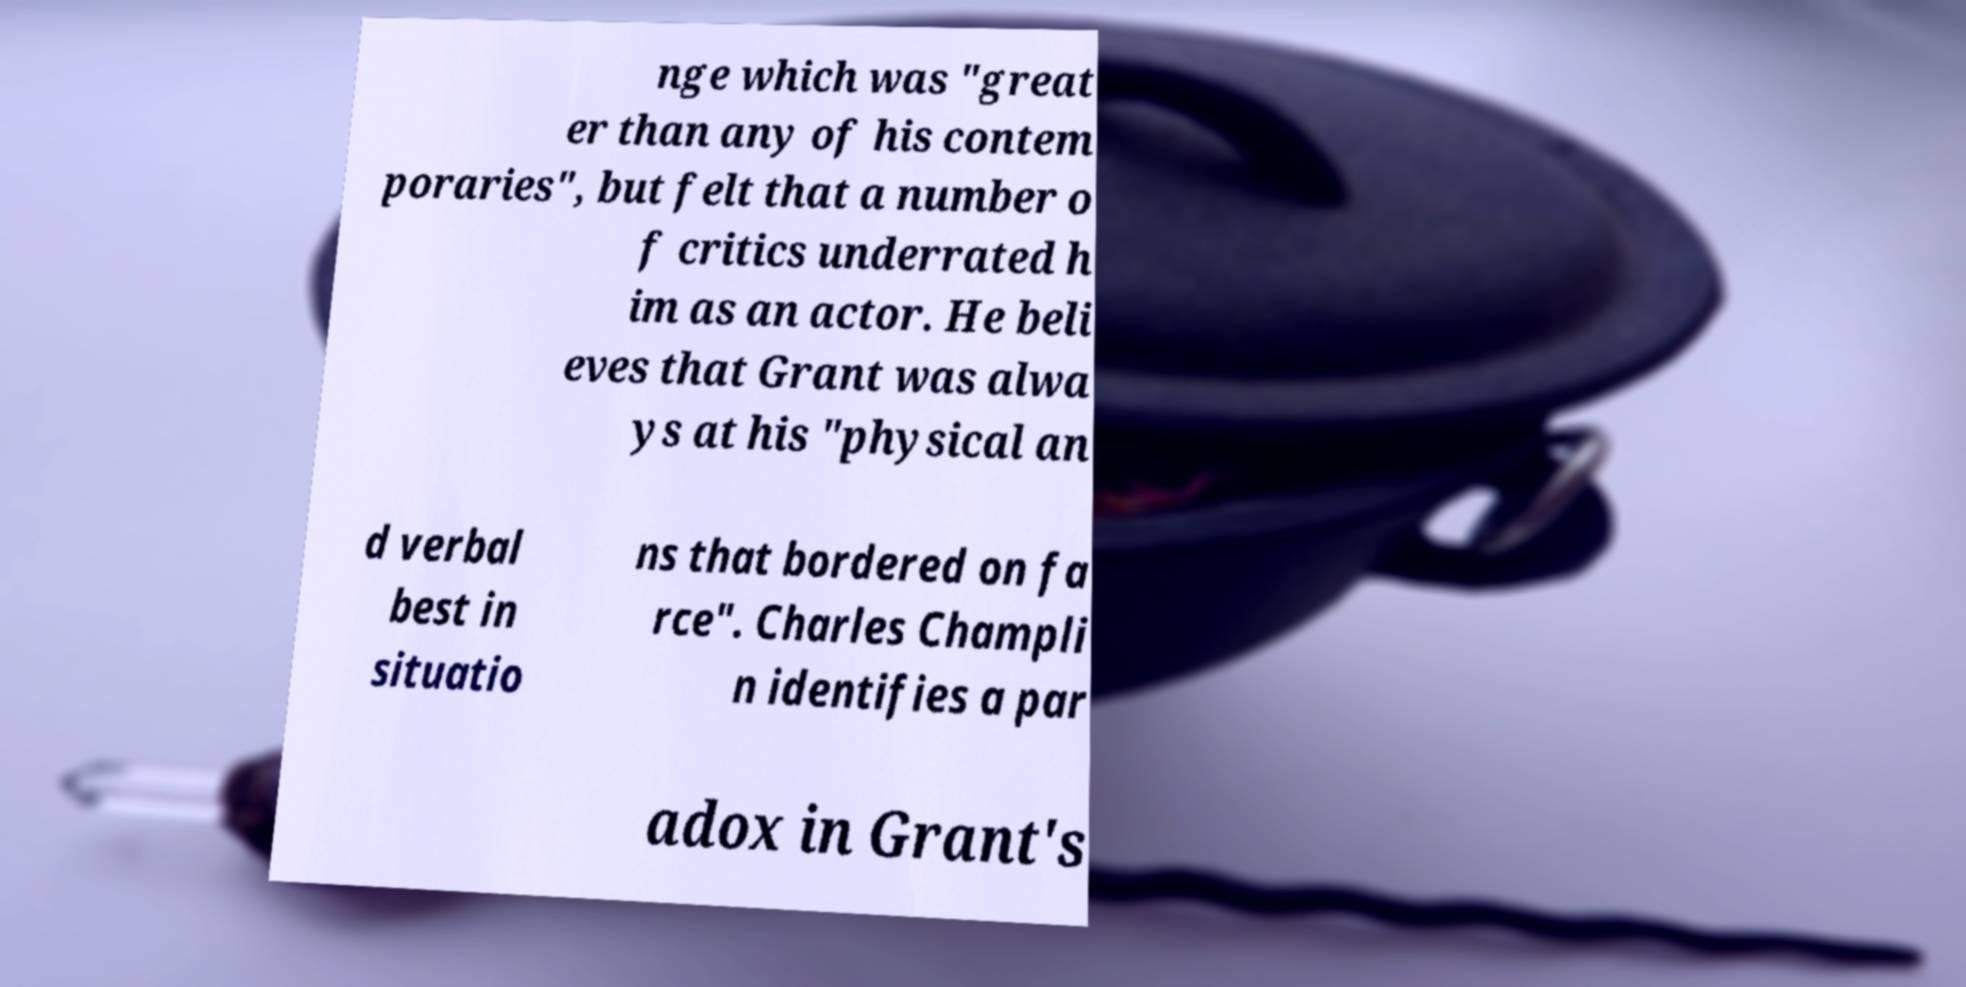Can you read and provide the text displayed in the image?This photo seems to have some interesting text. Can you extract and type it out for me? nge which was "great er than any of his contem poraries", but felt that a number o f critics underrated h im as an actor. He beli eves that Grant was alwa ys at his "physical an d verbal best in situatio ns that bordered on fa rce". Charles Champli n identifies a par adox in Grant's 